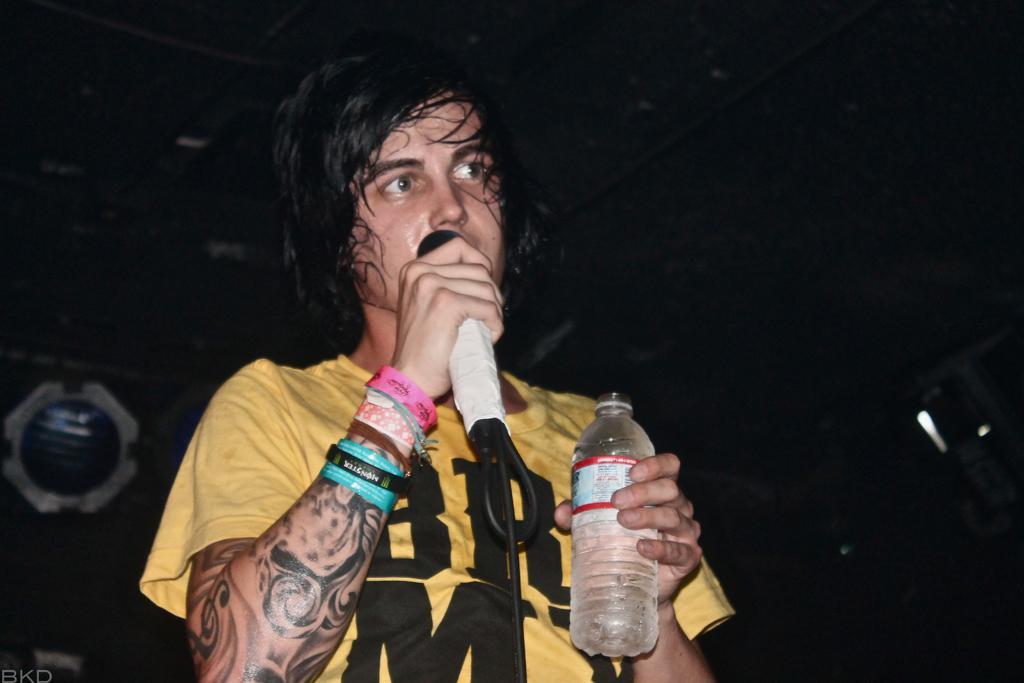Can you describe this image briefly? A person wearing a yellow and black t shirt is holding a mic and bottle. And there are wrist bands on the hands. 